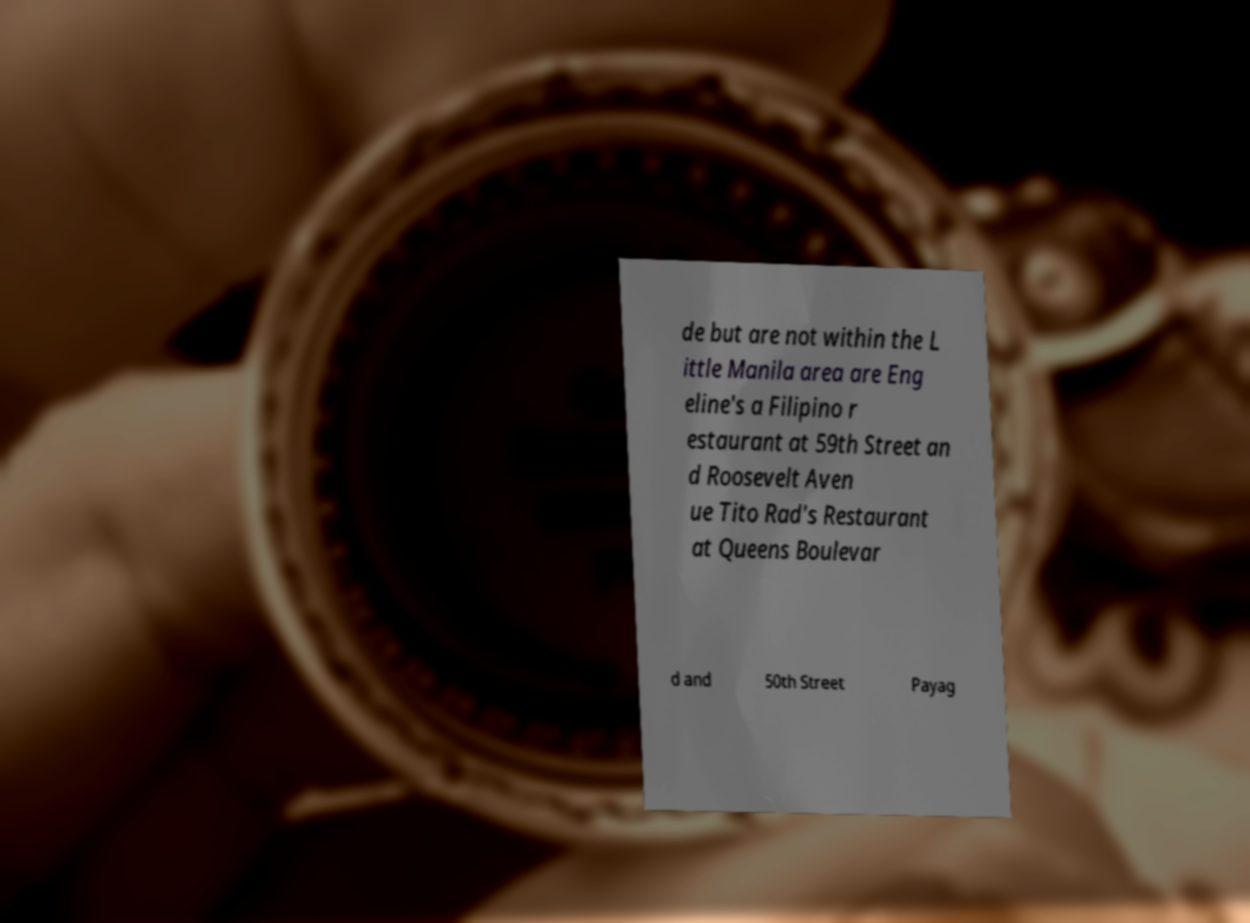Please read and relay the text visible in this image. What does it say? de but are not within the L ittle Manila area are Eng eline's a Filipino r estaurant at 59th Street an d Roosevelt Aven ue Tito Rad's Restaurant at Queens Boulevar d and 50th Street Payag 